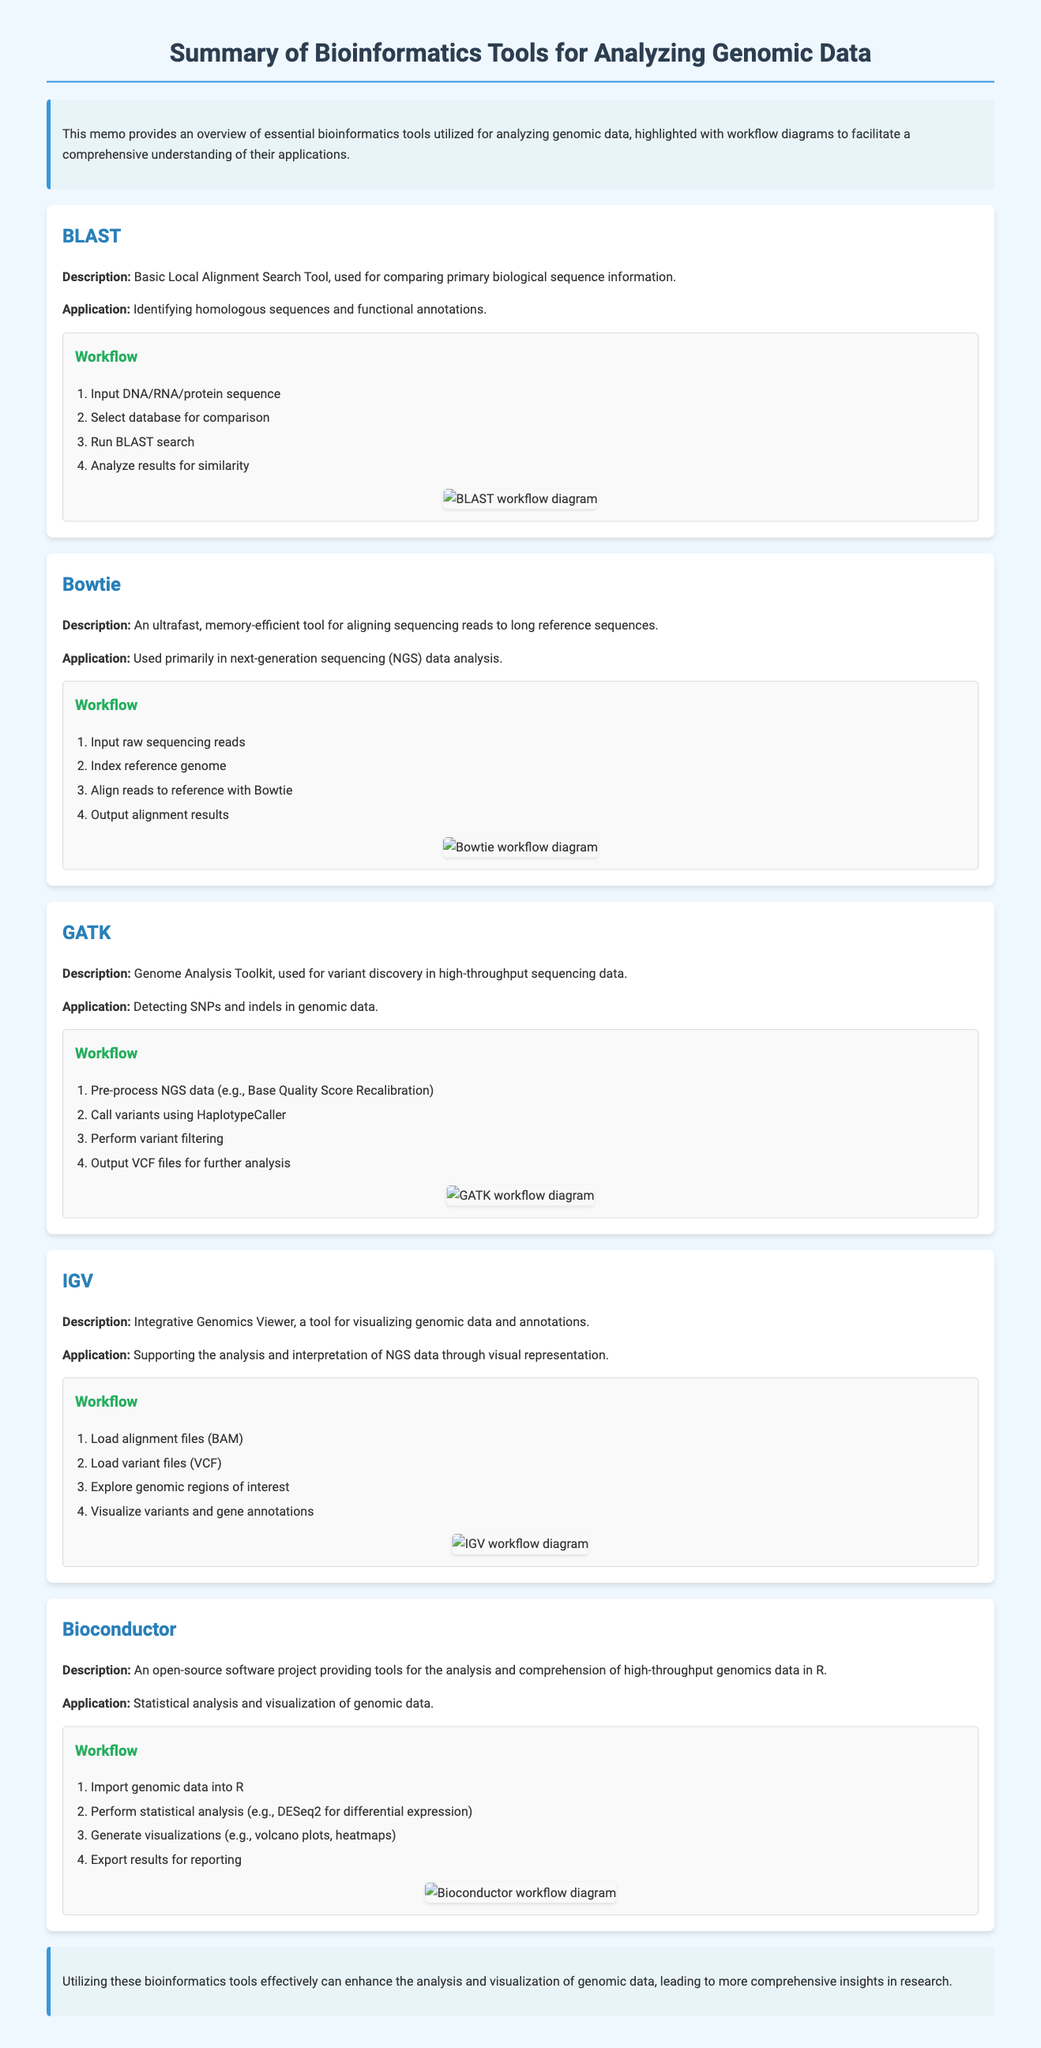What is the title of the document? The title is indicated at the top of the document as the main heading.
Answer: Summary of Bioinformatics Tools for Analyzing Genomic Data How many bioinformatics tools are summarized in the document? There are five distinct tools detailed in the sections of the memo.
Answer: Five What is the primary application of GATK? The application focuses on variant discovery in high-throughput sequencing data as stated in the description.
Answer: Detecting SNPs and indels What tool is used for visualizing genomic data? The document specifies that IGV is a tool dedicated to this purpose.
Answer: IGV In which step of the BLAST workflow are results analyzed? The workflow outlines that results are analyzed after the BLAST search is executed.
Answer: Analyze results for similarity What is one of the visual representation outputs generated by Bioconductor? The document mentions specific visual outputs that are created for reporting purposes.
Answer: Volcano plots What is the first step in the Bowtie workflow? The first step is listed as inputting the raw sequencing reads necessary for the alignment process.
Answer: Input raw sequencing reads What type of project is Bioconductor described as? The document describes Bioconductor as an open-source software project aimed at genomic data analysis.
Answer: Open-source software project What color highlights the conclusion section? The color used for the conclusion section is specified within the styling of the document.
Answer: Light blue 